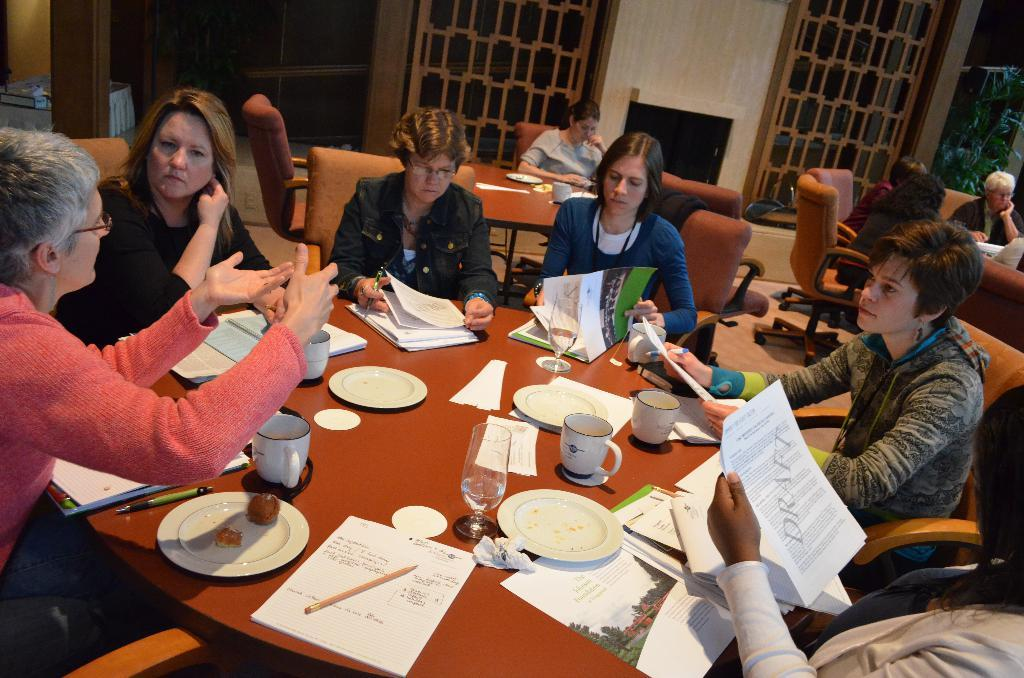How many people are in the image? There is a group of people in the image. What are the people doing in the image? The people are sitting on chairs. What is on the table in the image? There is a plate, a pen, a glass, a cup, a saucer, and a food item on the table. What can be seen in the background of the image? In the background of the image, there are windows and trees. How many dolls are sitting on the chairs with the people in the image? There are no dolls present in the image; only people are sitting on the chairs. What type of metal is the table made of in the image? The type of metal the table is made of is not mentioned in the image, so it cannot be determined. 